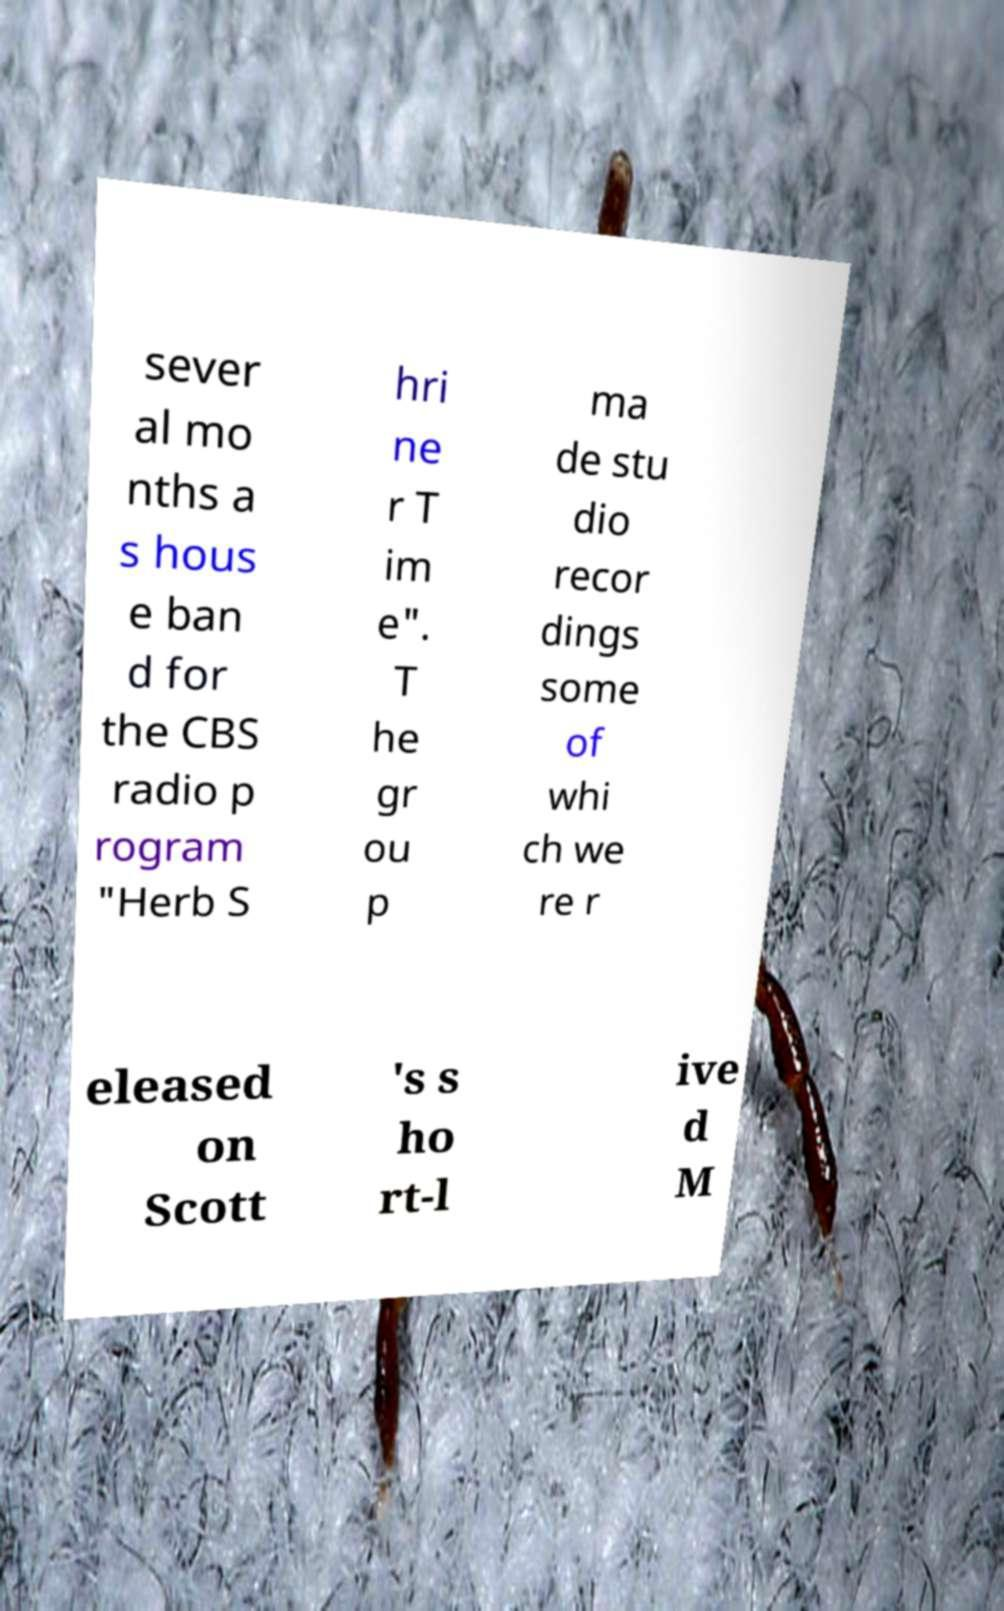I need the written content from this picture converted into text. Can you do that? sever al mo nths a s hous e ban d for the CBS radio p rogram "Herb S hri ne r T im e". T he gr ou p ma de stu dio recor dings some of whi ch we re r eleased on Scott 's s ho rt-l ive d M 